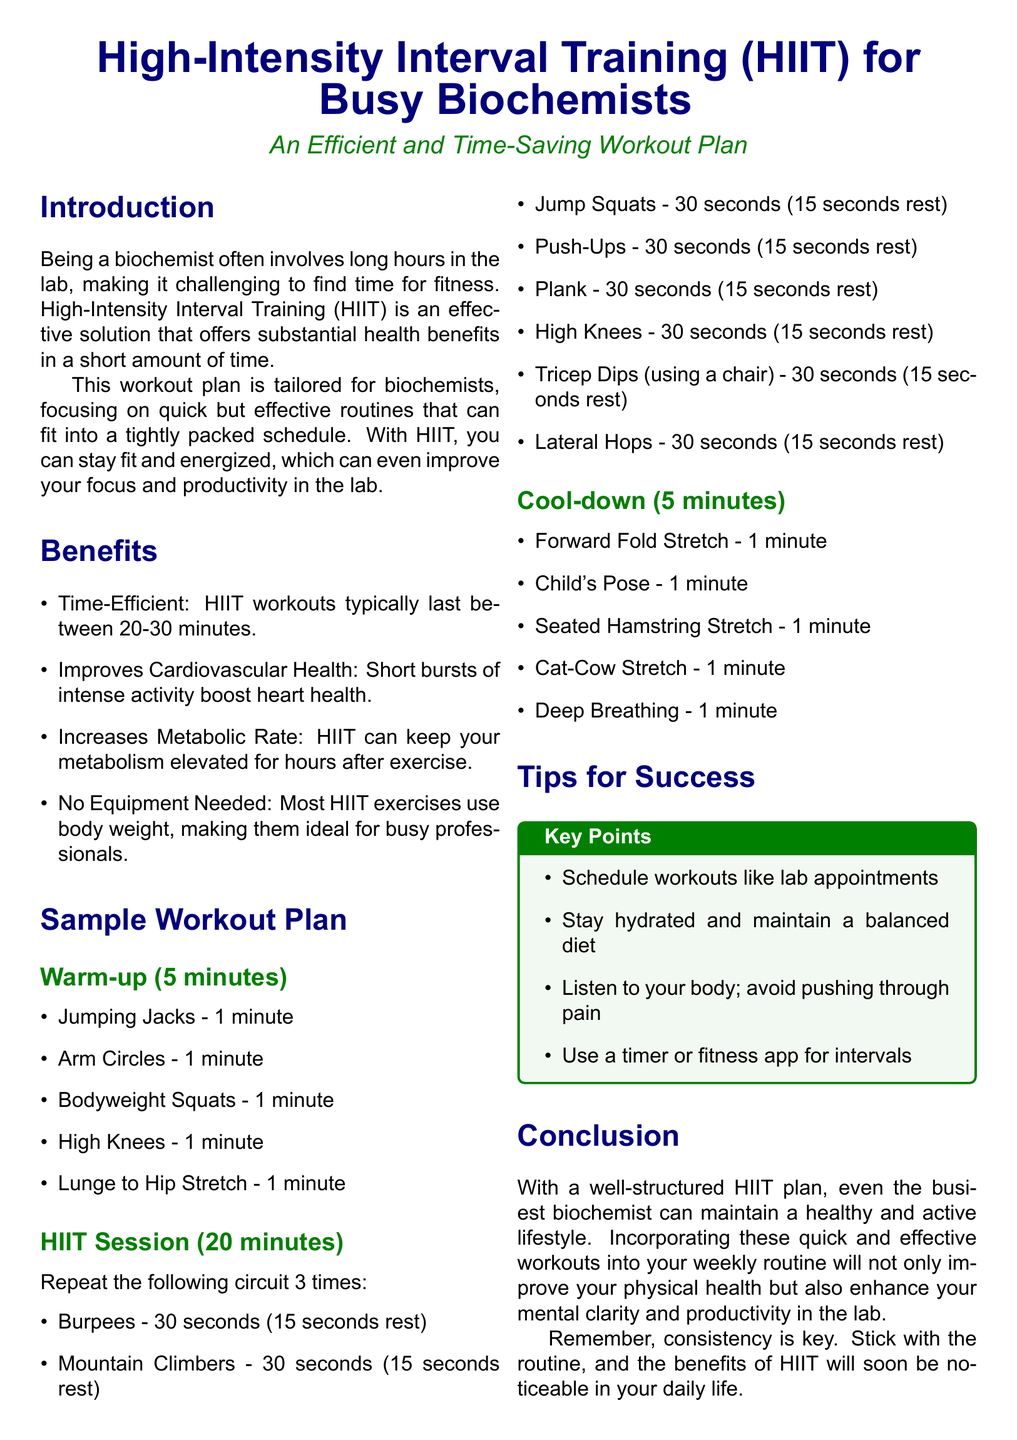what is the total duration of the HIIT session? The HIIT session is described to last for a duration of 20 minutes.
Answer: 20 minutes how many times should the circuit be repeated? The document states the circuit should be repeated 3 times during the HIIT session.
Answer: 3 times what is the first exercise in the warm-up? The first exercise listed in the warm-up section is Jumping Jacks.
Answer: Jumping Jacks which exercise requires a chair? The exercise that requires a chair is Tricep Dips.
Answer: Tricep Dips what should you maintain along with staying hydrated? The document advises maintaining a balanced diet along with hydration.
Answer: balanced diet how long does the cool-down section last? The cool-down section is specified to last for 5 minutes.
Answer: 5 minutes what is a key benefit of HIIT mentioned? One key benefit of HIIT mentioned is that it improves cardiovascular health.
Answer: Improves Cardiovascular Health what is a suggested method to keep track of intervals? A suggested method mentioned for tracking intervals is to use a timer or fitness app.
Answer: timer or fitness app 